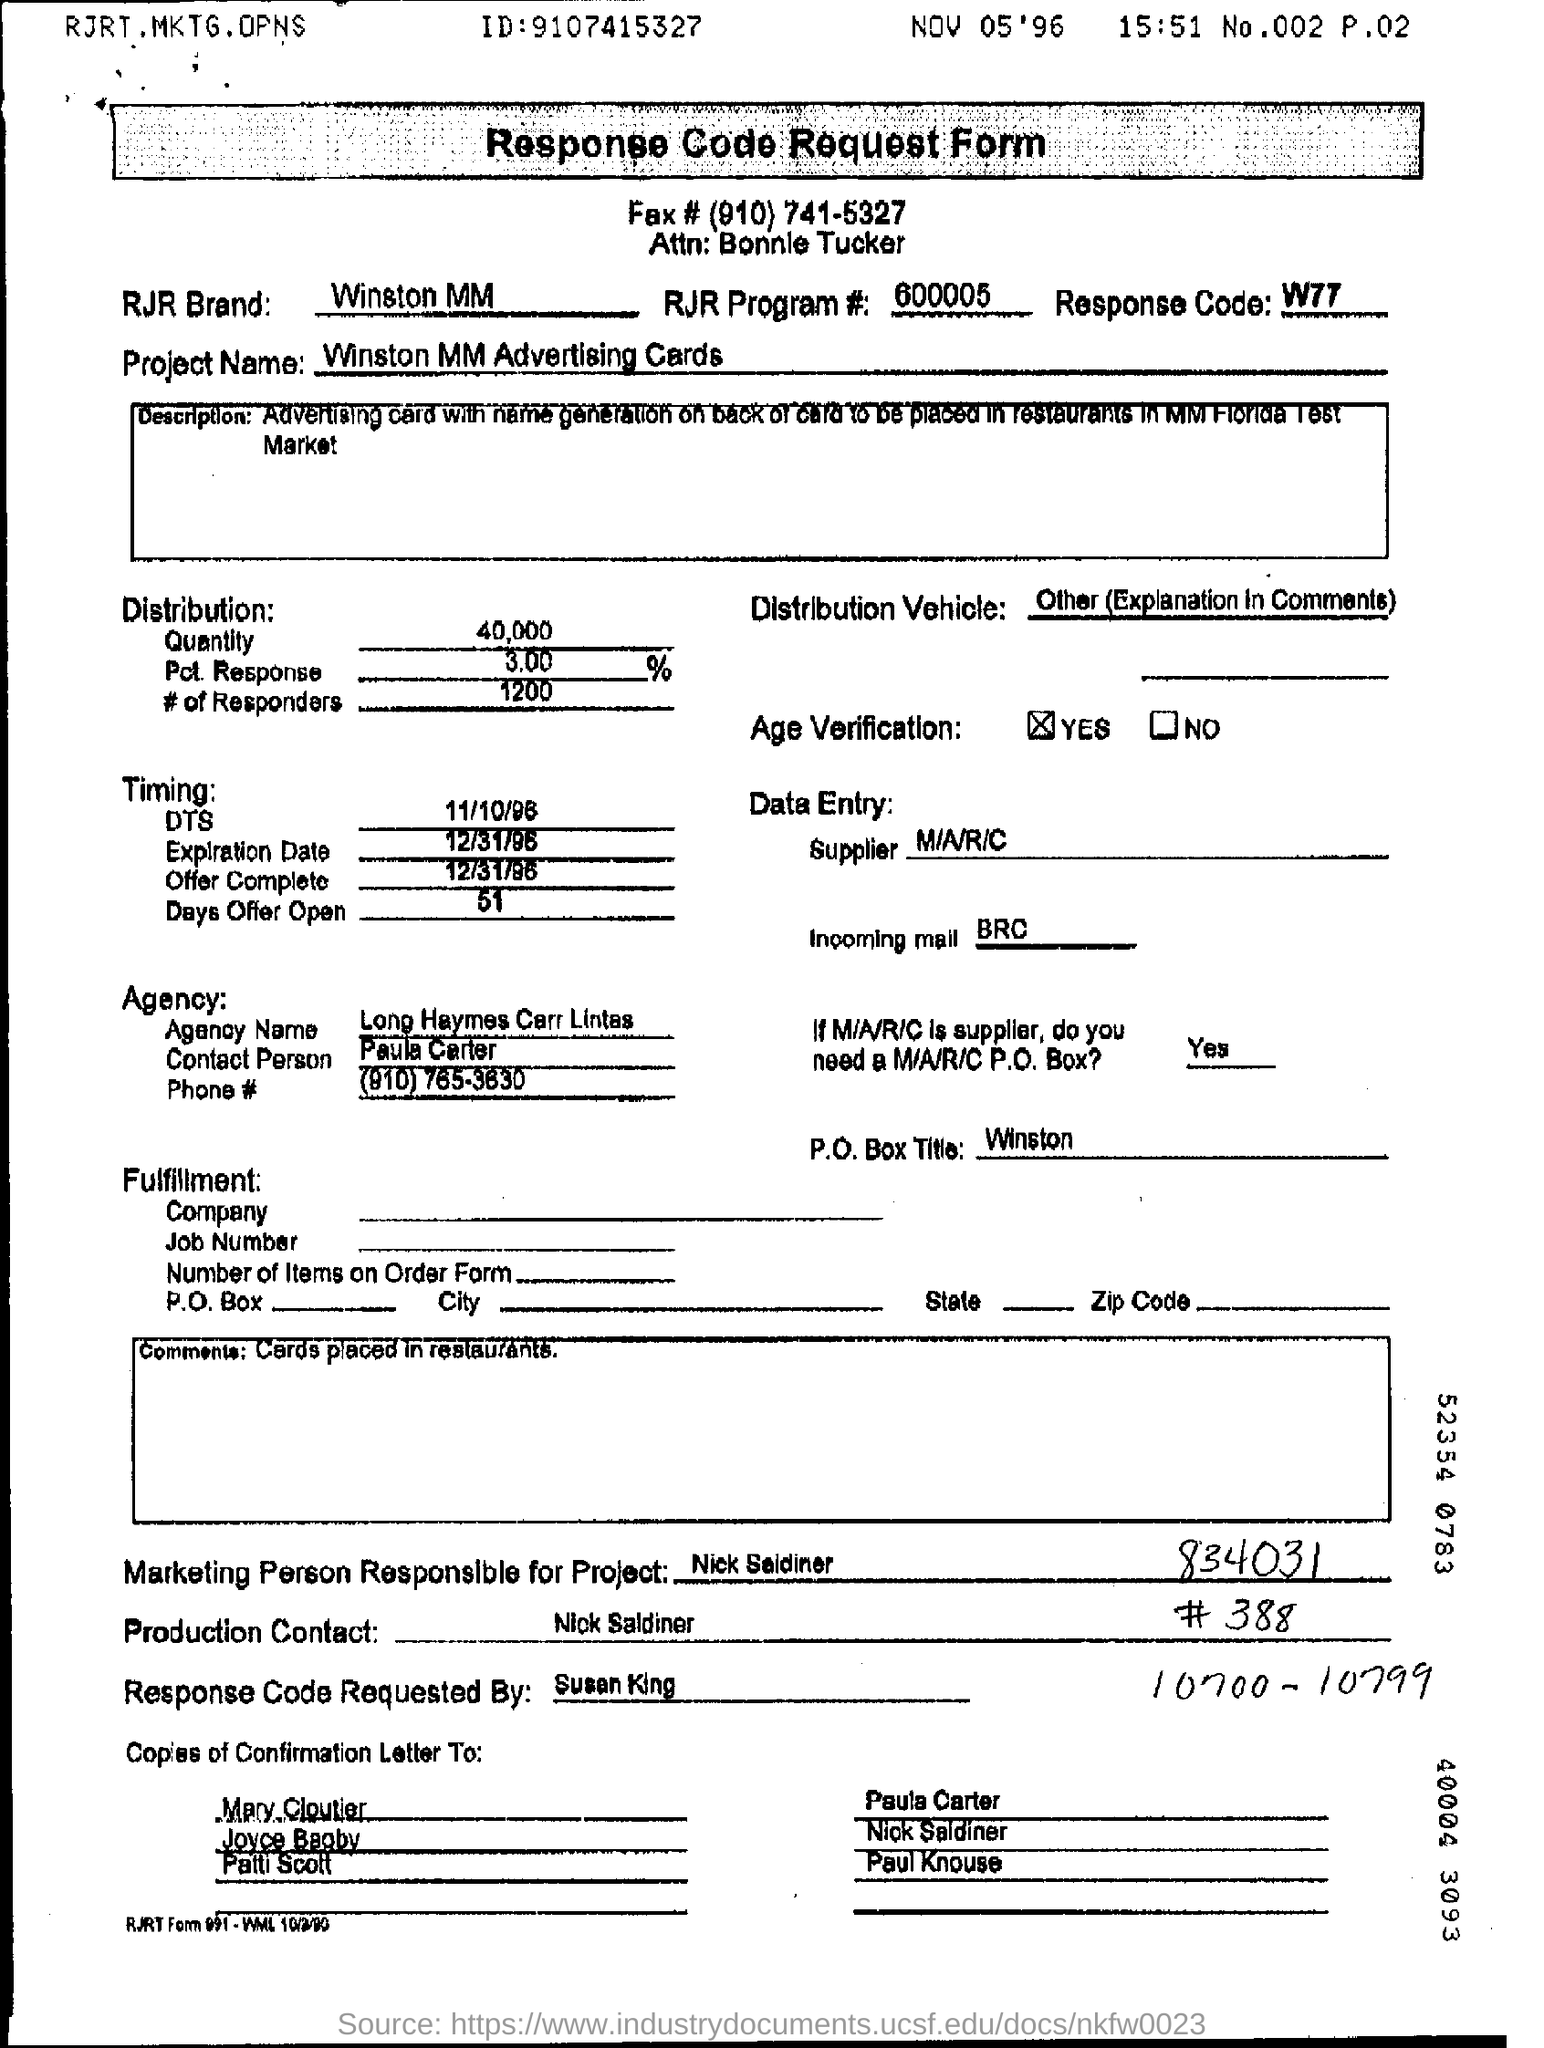Mention a couple of crucial points in this snapshot. The distribution quantity is 40,000. The data entry supplier is M/A/R/C... The response code is W77. The agency name is "Long Haymes Carr Lintas. The RJR brand is a company that manufactures and sells cigarettes, specifically the Winston MM brand. 